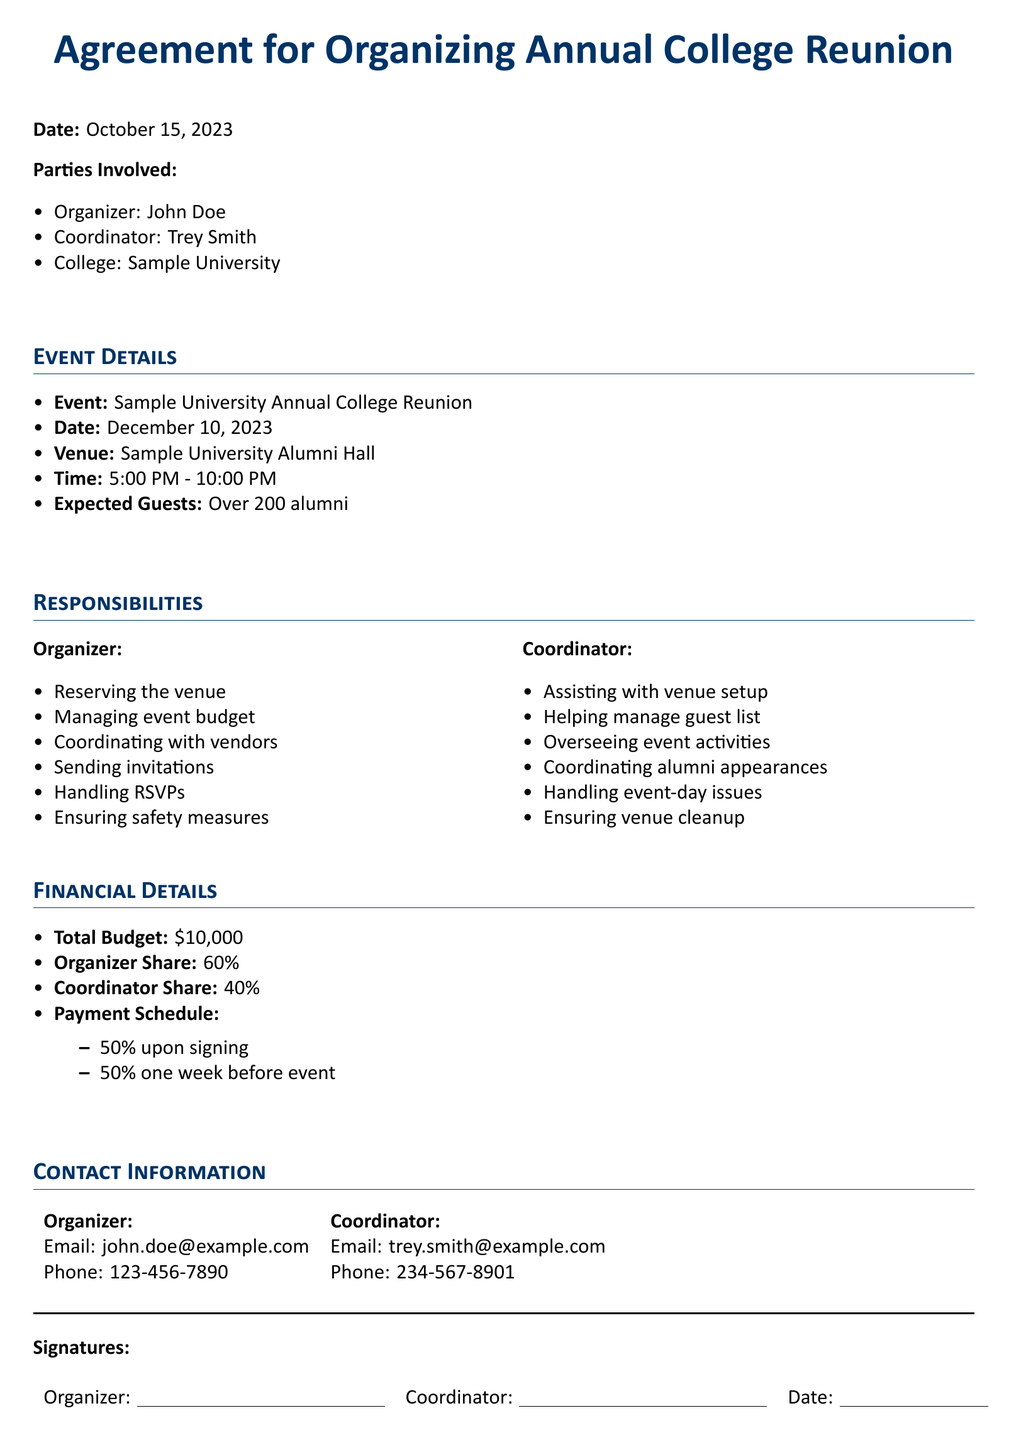What is the date of the event? The date of the event is specified in the document under Event Details.
Answer: December 10, 2023 Who is the coordinator for the reunion? The document lists the coordinator involved in organizing the reunion.
Answer: Trey Smith What percentage of the budget does the organizer receive? The organizer's share is mentioned in the Financial Details section of the document.
Answer: 60% What is the total budget allocated for the event? The total budget for the reunion is detailed in the Financial Details section.
Answer: $10,000 What is the expected number of guests? The expected number of guests is stated in the Event Details section.
Answer: Over 200 alumni What responsibilities does the organizer have? Responsibilities of the organizer are listed and can be found in the Responsibilities section of the document.
Answer: Reserving the venue What time does the event start? The starting time of the event is noted in the Event Details section.
Answer: 5:00 PM What is the payment schedule? The document specifies how payments are scheduled in the Financial Details section.
Answer: 50% upon signing, 50% one week before event What is the email address of the organizer? The document provides contact information, including email addresses in the Contact Information section.
Answer: john.doe@example.com 